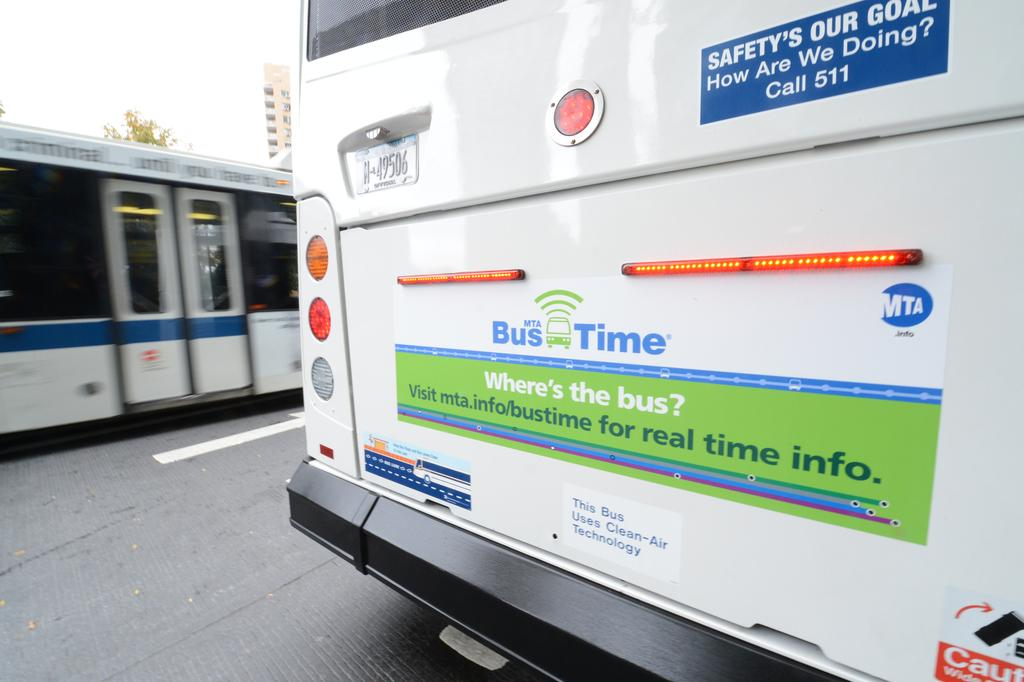What type of vehicle is on the road in the image? There is a vehicle on the road in the image, but the specific type is not mentioned. What other mode of transportation can be seen in the image? There is a train in the image. What can be seen in the background of the image? There is a building, a tree, and the sky visible in the background. What type of spark can be seen coming from the committee in the image? There is no committee present in the image, so there cannot be any sparks coming from it. 